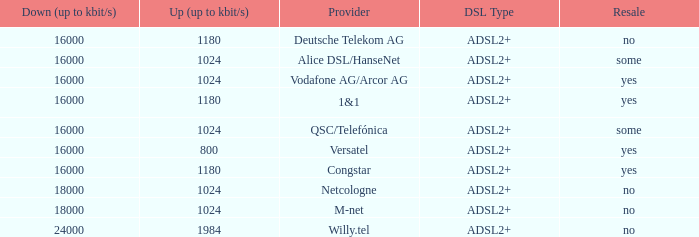What is download bandwith where the provider is deutsche telekom ag? 16000.0. 